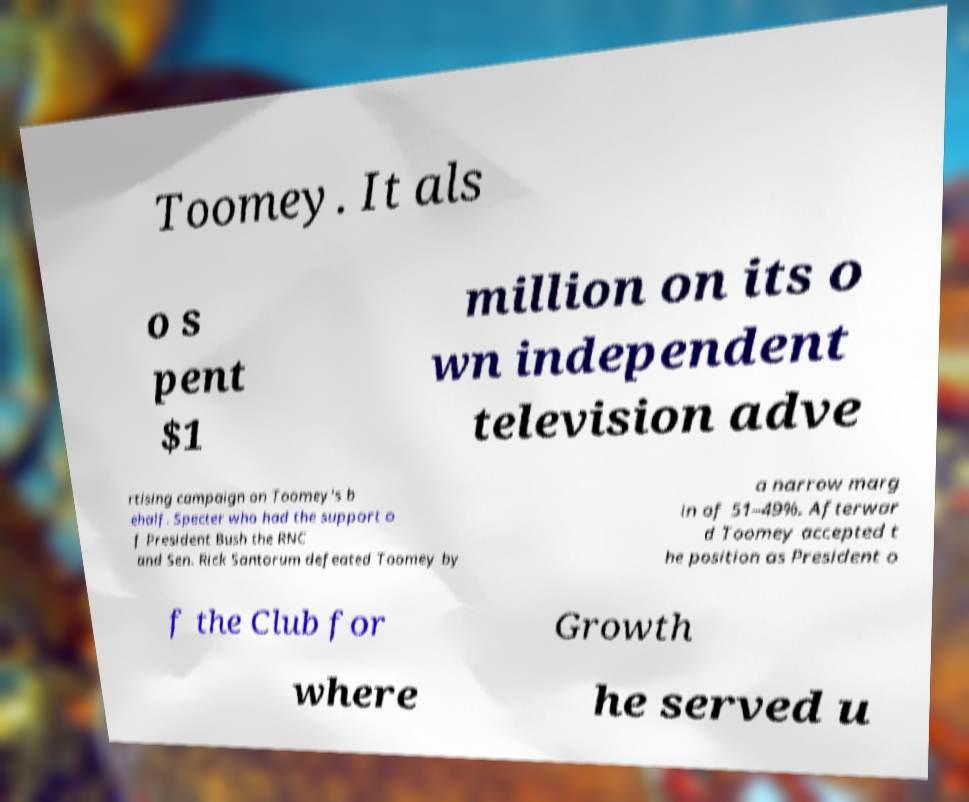Can you accurately transcribe the text from the provided image for me? Toomey. It als o s pent $1 million on its o wn independent television adve rtising campaign on Toomey's b ehalf. Specter who had the support o f President Bush the RNC and Sen. Rick Santorum defeated Toomey by a narrow marg in of 51–49%. Afterwar d Toomey accepted t he position as President o f the Club for Growth where he served u 